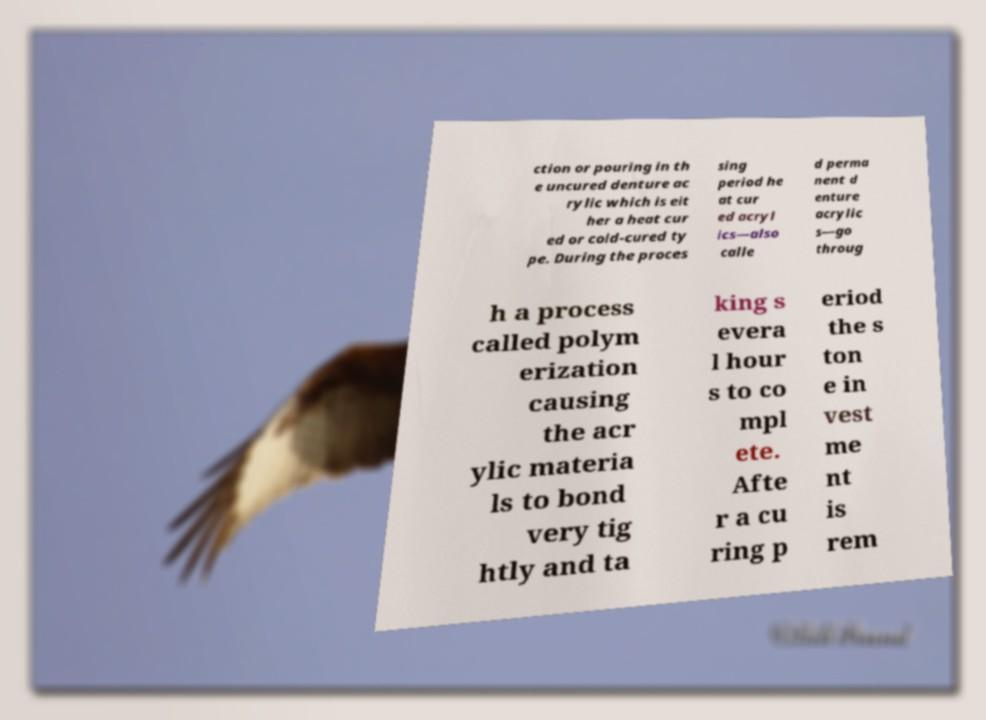Can you read and provide the text displayed in the image?This photo seems to have some interesting text. Can you extract and type it out for me? ction or pouring in th e uncured denture ac rylic which is eit her a heat cur ed or cold-cured ty pe. During the proces sing period he at cur ed acryl ics—also calle d perma nent d enture acrylic s—go throug h a process called polym erization causing the acr ylic materia ls to bond very tig htly and ta king s evera l hour s to co mpl ete. Afte r a cu ring p eriod the s ton e in vest me nt is rem 